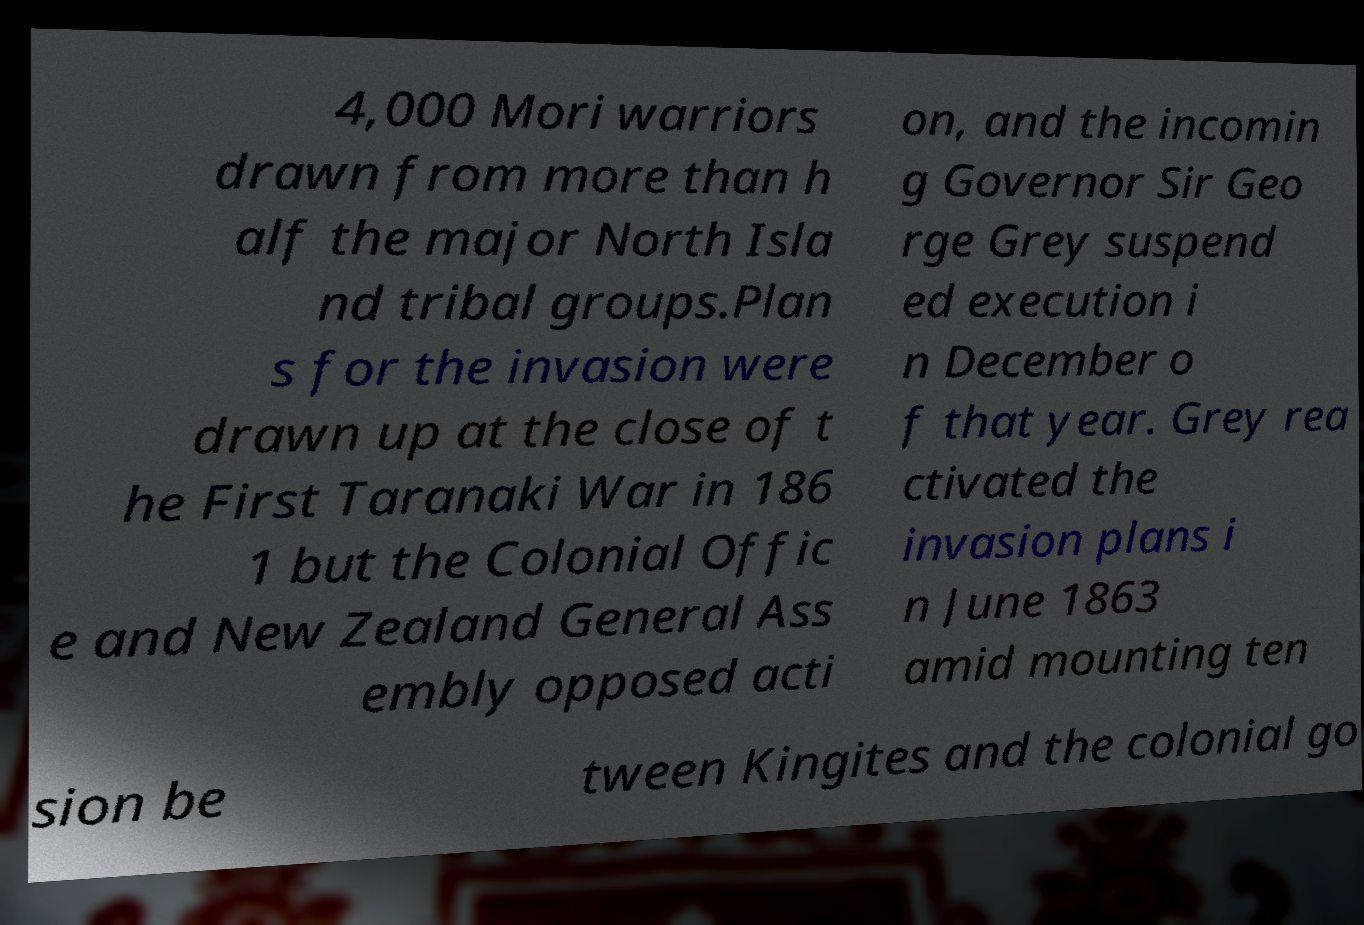Please read and relay the text visible in this image. What does it say? 4,000 Mori warriors drawn from more than h alf the major North Isla nd tribal groups.Plan s for the invasion were drawn up at the close of t he First Taranaki War in 186 1 but the Colonial Offic e and New Zealand General Ass embly opposed acti on, and the incomin g Governor Sir Geo rge Grey suspend ed execution i n December o f that year. Grey rea ctivated the invasion plans i n June 1863 amid mounting ten sion be tween Kingites and the colonial go 